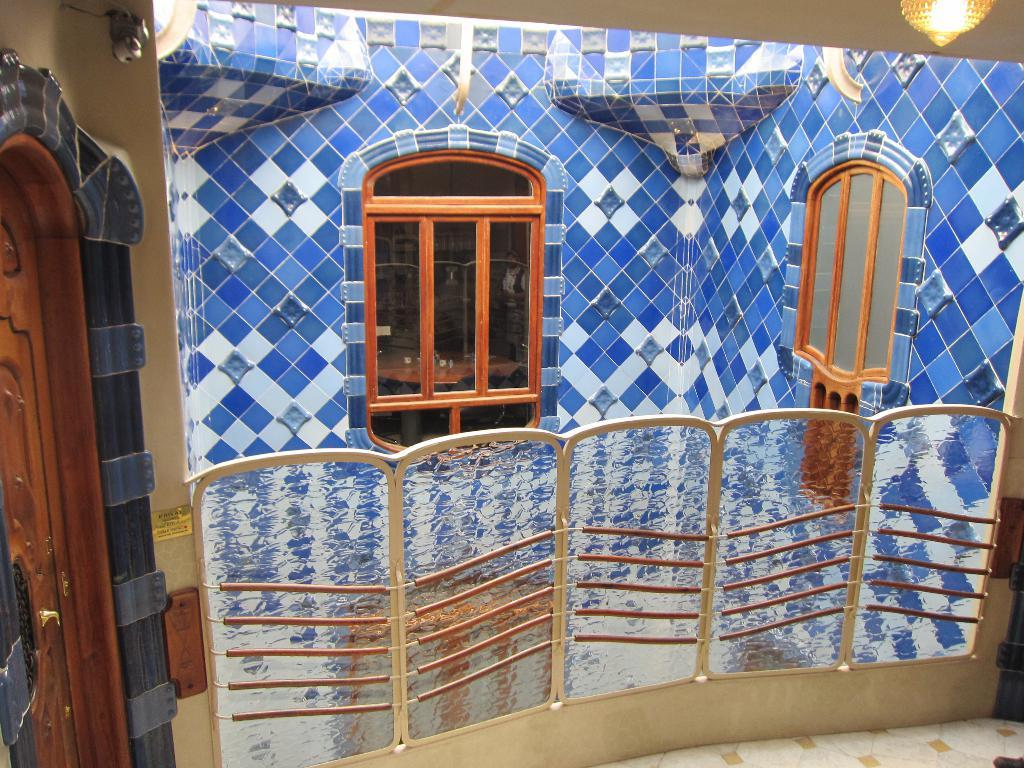What part of a building is shown in the image? The image shows the inner part of a building. What is one feature that allows access to different areas of the building? There is a door in the image. How can natural light enter the building in the image? There are windows in the image. What safety feature is present in the image? There is a railing in the image. What provides illumination in the image? There is a light in the image. How would you describe the appearance of the wall in the image? The wall has a colorful appearance. How many pictures are hanging on the wall in the image? There is no picture hanging on the wall in the image; it has a colorful appearance. Is the environment in the image quiet or noisy? The image does not provide any information about the noise level in the environment. 